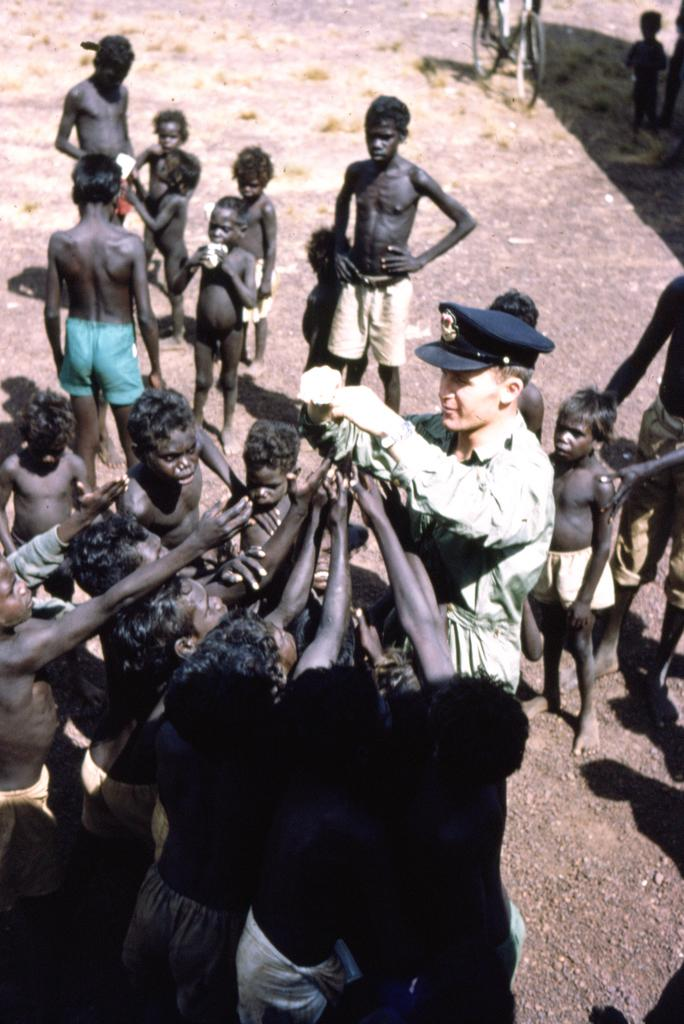What is the main subject of the image? The main subject of the image is a group of people in the center. What can be seen in the background of the image? There is ground visible in the background of the image. What other object is present in the image? A bicycle is present at the top of the image. What type of liquid is being consumed by the pig in the image? There is no pig present in the image, so it is not possible to answer that question. 